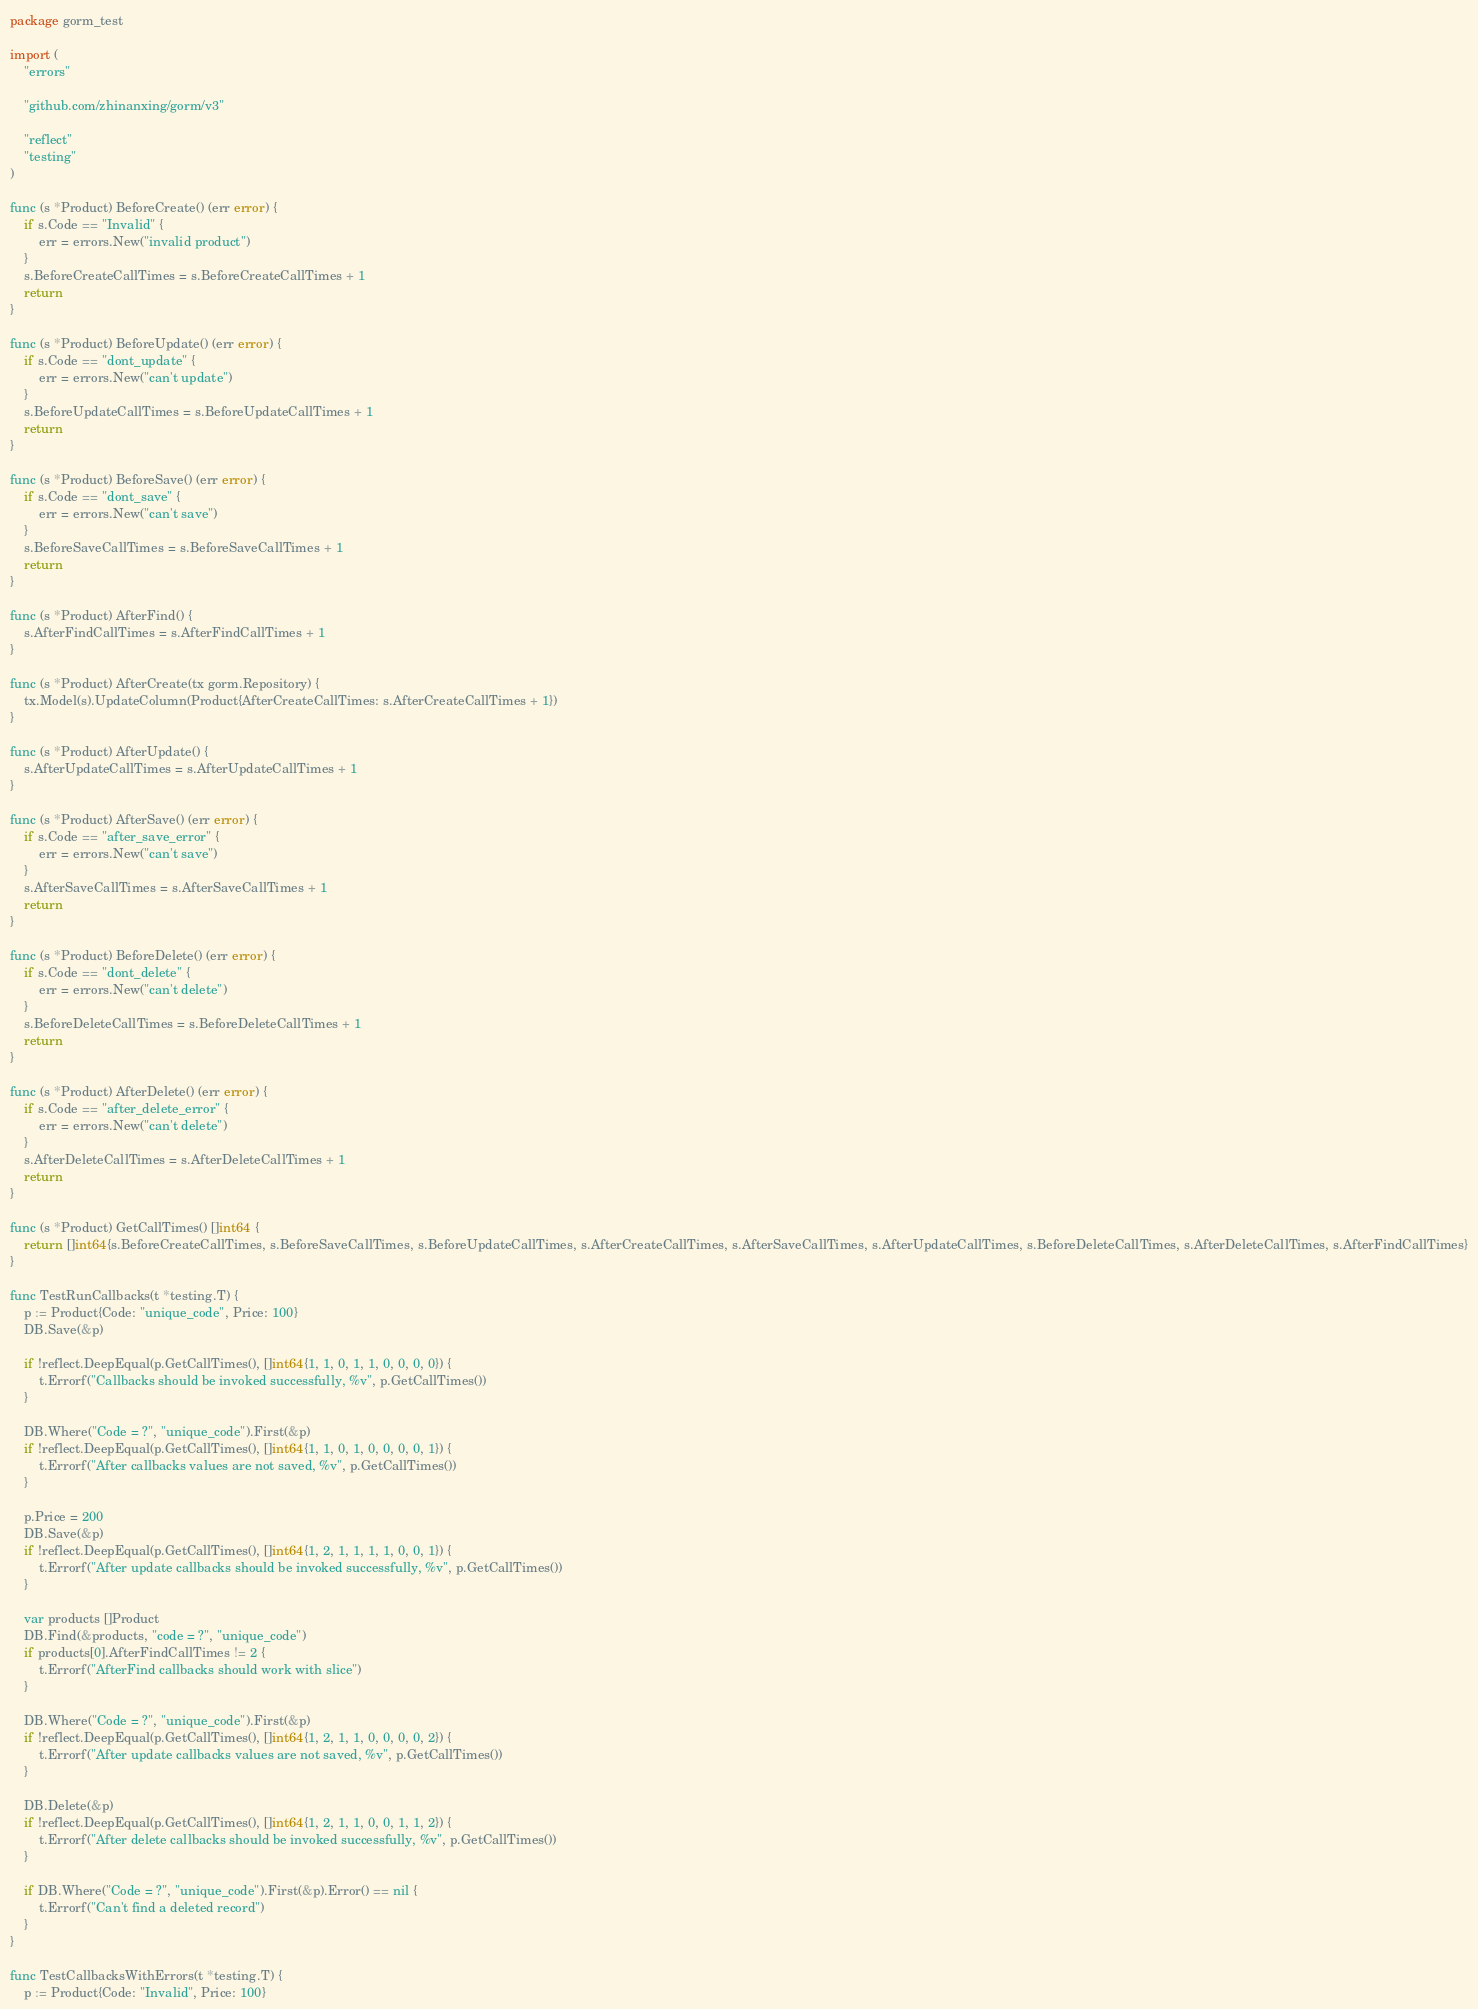<code> <loc_0><loc_0><loc_500><loc_500><_Go_>package gorm_test

import (
	"errors"

	"github.com/zhinanxing/gorm/v3"

	"reflect"
	"testing"
)

func (s *Product) BeforeCreate() (err error) {
	if s.Code == "Invalid" {
		err = errors.New("invalid product")
	}
	s.BeforeCreateCallTimes = s.BeforeCreateCallTimes + 1
	return
}

func (s *Product) BeforeUpdate() (err error) {
	if s.Code == "dont_update" {
		err = errors.New("can't update")
	}
	s.BeforeUpdateCallTimes = s.BeforeUpdateCallTimes + 1
	return
}

func (s *Product) BeforeSave() (err error) {
	if s.Code == "dont_save" {
		err = errors.New("can't save")
	}
	s.BeforeSaveCallTimes = s.BeforeSaveCallTimes + 1
	return
}

func (s *Product) AfterFind() {
	s.AfterFindCallTimes = s.AfterFindCallTimes + 1
}

func (s *Product) AfterCreate(tx gorm.Repository) {
	tx.Model(s).UpdateColumn(Product{AfterCreateCallTimes: s.AfterCreateCallTimes + 1})
}

func (s *Product) AfterUpdate() {
	s.AfterUpdateCallTimes = s.AfterUpdateCallTimes + 1
}

func (s *Product) AfterSave() (err error) {
	if s.Code == "after_save_error" {
		err = errors.New("can't save")
	}
	s.AfterSaveCallTimes = s.AfterSaveCallTimes + 1
	return
}

func (s *Product) BeforeDelete() (err error) {
	if s.Code == "dont_delete" {
		err = errors.New("can't delete")
	}
	s.BeforeDeleteCallTimes = s.BeforeDeleteCallTimes + 1
	return
}

func (s *Product) AfterDelete() (err error) {
	if s.Code == "after_delete_error" {
		err = errors.New("can't delete")
	}
	s.AfterDeleteCallTimes = s.AfterDeleteCallTimes + 1
	return
}

func (s *Product) GetCallTimes() []int64 {
	return []int64{s.BeforeCreateCallTimes, s.BeforeSaveCallTimes, s.BeforeUpdateCallTimes, s.AfterCreateCallTimes, s.AfterSaveCallTimes, s.AfterUpdateCallTimes, s.BeforeDeleteCallTimes, s.AfterDeleteCallTimes, s.AfterFindCallTimes}
}

func TestRunCallbacks(t *testing.T) {
	p := Product{Code: "unique_code", Price: 100}
	DB.Save(&p)

	if !reflect.DeepEqual(p.GetCallTimes(), []int64{1, 1, 0, 1, 1, 0, 0, 0, 0}) {
		t.Errorf("Callbacks should be invoked successfully, %v", p.GetCallTimes())
	}

	DB.Where("Code = ?", "unique_code").First(&p)
	if !reflect.DeepEqual(p.GetCallTimes(), []int64{1, 1, 0, 1, 0, 0, 0, 0, 1}) {
		t.Errorf("After callbacks values are not saved, %v", p.GetCallTimes())
	}

	p.Price = 200
	DB.Save(&p)
	if !reflect.DeepEqual(p.GetCallTimes(), []int64{1, 2, 1, 1, 1, 1, 0, 0, 1}) {
		t.Errorf("After update callbacks should be invoked successfully, %v", p.GetCallTimes())
	}

	var products []Product
	DB.Find(&products, "code = ?", "unique_code")
	if products[0].AfterFindCallTimes != 2 {
		t.Errorf("AfterFind callbacks should work with slice")
	}

	DB.Where("Code = ?", "unique_code").First(&p)
	if !reflect.DeepEqual(p.GetCallTimes(), []int64{1, 2, 1, 1, 0, 0, 0, 0, 2}) {
		t.Errorf("After update callbacks values are not saved, %v", p.GetCallTimes())
	}

	DB.Delete(&p)
	if !reflect.DeepEqual(p.GetCallTimes(), []int64{1, 2, 1, 1, 0, 0, 1, 1, 2}) {
		t.Errorf("After delete callbacks should be invoked successfully, %v", p.GetCallTimes())
	}

	if DB.Where("Code = ?", "unique_code").First(&p).Error() == nil {
		t.Errorf("Can't find a deleted record")
	}
}

func TestCallbacksWithErrors(t *testing.T) {
	p := Product{Code: "Invalid", Price: 100}</code> 